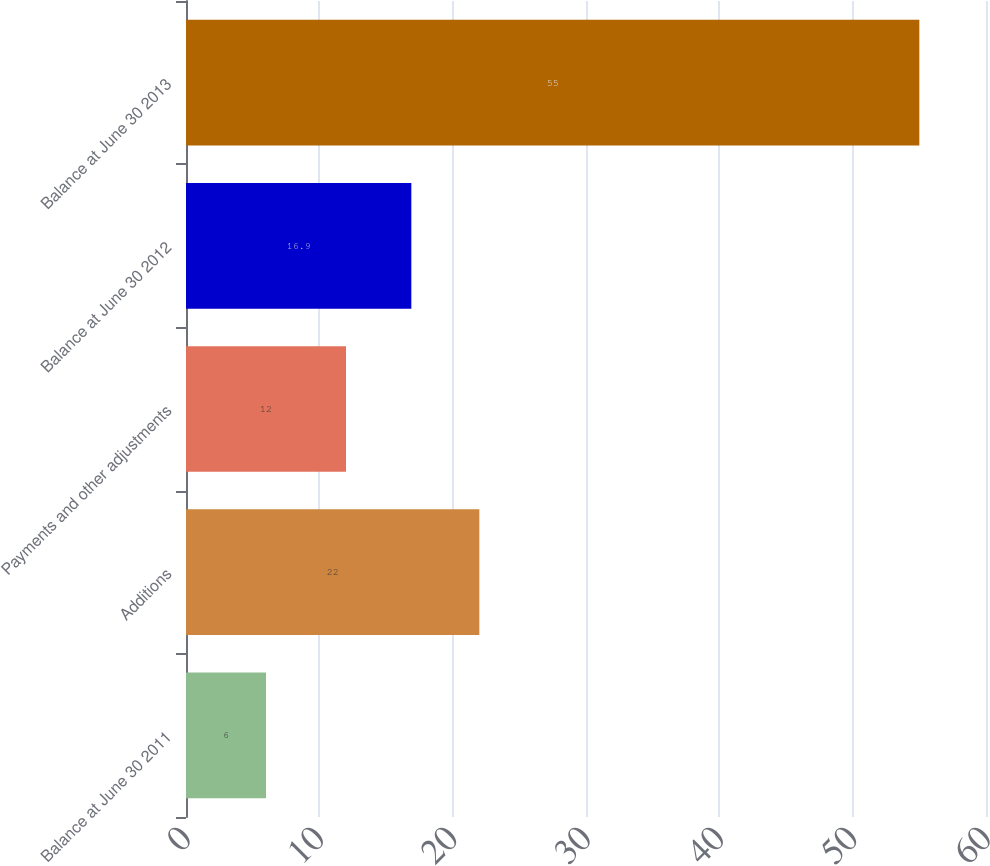Convert chart. <chart><loc_0><loc_0><loc_500><loc_500><bar_chart><fcel>Balance at June 30 2011<fcel>Additions<fcel>Payments and other adjustments<fcel>Balance at June 30 2012<fcel>Balance at June 30 2013<nl><fcel>6<fcel>22<fcel>12<fcel>16.9<fcel>55<nl></chart> 